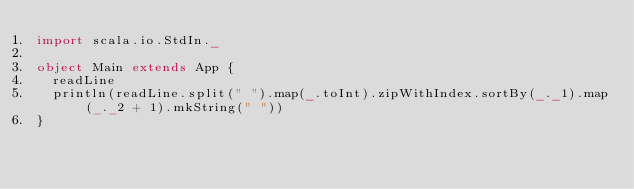Convert code to text. <code><loc_0><loc_0><loc_500><loc_500><_Scala_>import scala.io.StdIn._

object Main extends App {
  readLine
  println(readLine.split(" ").map(_.toInt).zipWithIndex.sortBy(_._1).map(_._2 + 1).mkString(" "))
}</code> 